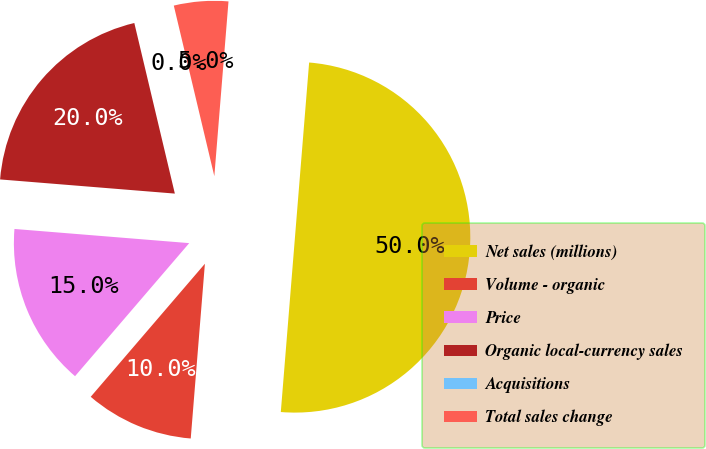Convert chart to OTSL. <chart><loc_0><loc_0><loc_500><loc_500><pie_chart><fcel>Net sales (millions)<fcel>Volume - organic<fcel>Price<fcel>Organic local-currency sales<fcel>Acquisitions<fcel>Total sales change<nl><fcel>50.0%<fcel>10.0%<fcel>15.0%<fcel>20.0%<fcel>0.0%<fcel>5.0%<nl></chart> 